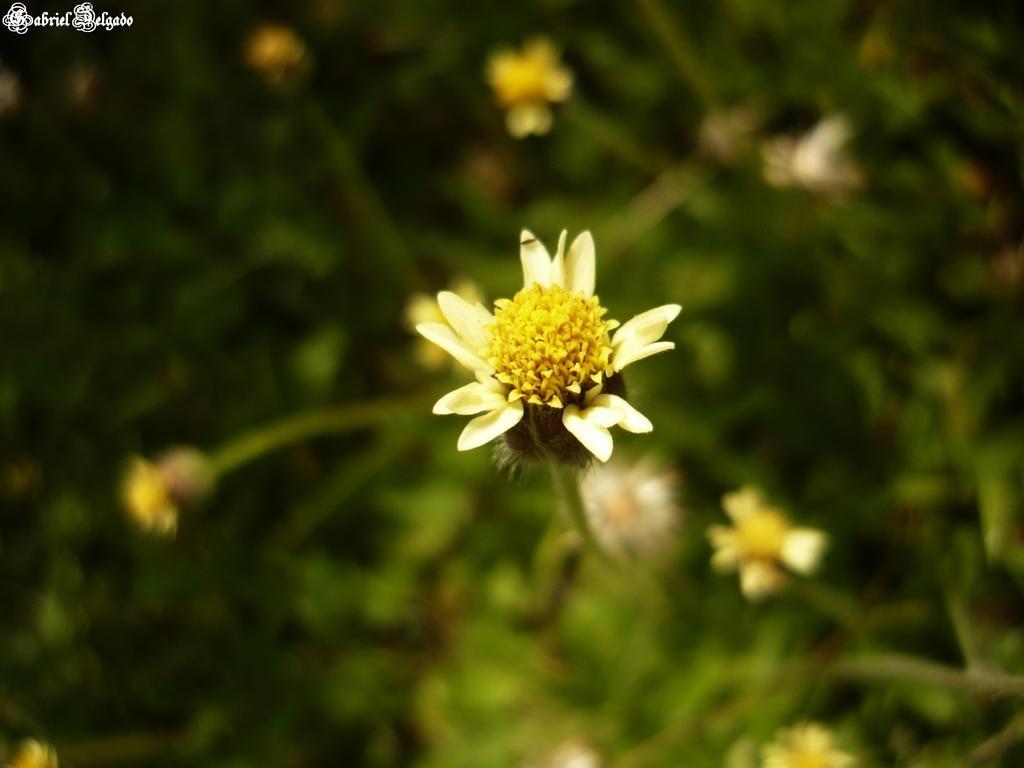Describe this image in one or two sentences. In this picture, we see the plants which have flowers. These flowers are in white and yellow color. In the background, we see the plants. This picture is blurred in the background. 